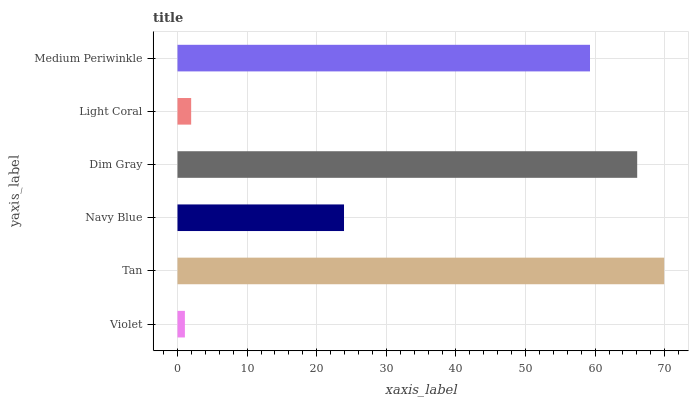Is Violet the minimum?
Answer yes or no. Yes. Is Tan the maximum?
Answer yes or no. Yes. Is Navy Blue the minimum?
Answer yes or no. No. Is Navy Blue the maximum?
Answer yes or no. No. Is Tan greater than Navy Blue?
Answer yes or no. Yes. Is Navy Blue less than Tan?
Answer yes or no. Yes. Is Navy Blue greater than Tan?
Answer yes or no. No. Is Tan less than Navy Blue?
Answer yes or no. No. Is Medium Periwinkle the high median?
Answer yes or no. Yes. Is Navy Blue the low median?
Answer yes or no. Yes. Is Violet the high median?
Answer yes or no. No. Is Light Coral the low median?
Answer yes or no. No. 